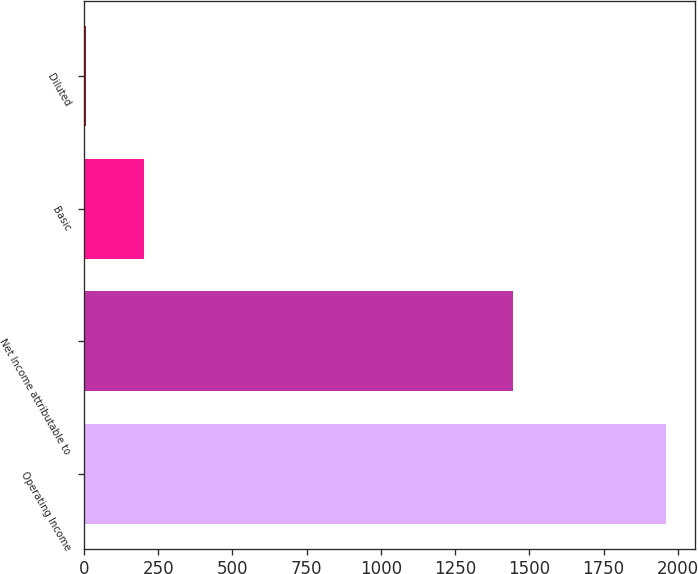Convert chart to OTSL. <chart><loc_0><loc_0><loc_500><loc_500><bar_chart><fcel>Operating Income<fcel>Net Income attributable to<fcel>Basic<fcel>Diluted<nl><fcel>1958.7<fcel>1445.7<fcel>201.57<fcel>6.33<nl></chart> 